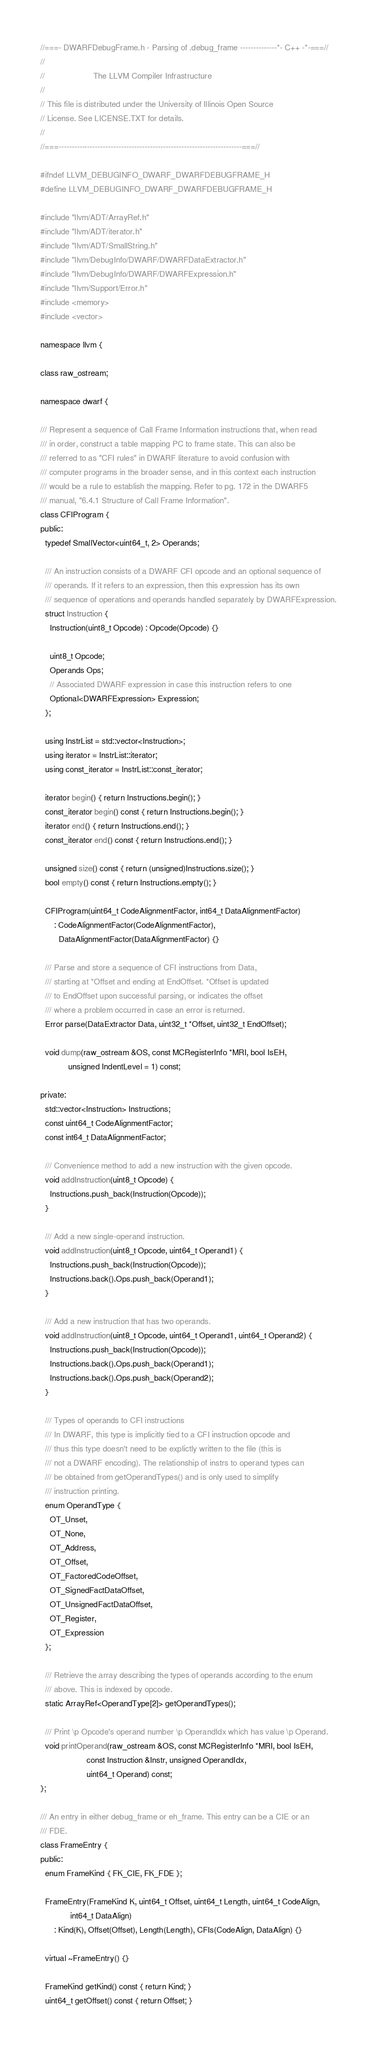Convert code to text. <code><loc_0><loc_0><loc_500><loc_500><_C_>//===- DWARFDebugFrame.h - Parsing of .debug_frame --------------*- C++ -*-===//
//
//                     The LLVM Compiler Infrastructure
//
// This file is distributed under the University of Illinois Open Source
// License. See LICENSE.TXT for details.
//
//===----------------------------------------------------------------------===//

#ifndef LLVM_DEBUGINFO_DWARF_DWARFDEBUGFRAME_H
#define LLVM_DEBUGINFO_DWARF_DWARFDEBUGFRAME_H

#include "llvm/ADT/ArrayRef.h"
#include "llvm/ADT/iterator.h"
#include "llvm/ADT/SmallString.h"
#include "llvm/DebugInfo/DWARF/DWARFDataExtractor.h"
#include "llvm/DebugInfo/DWARF/DWARFExpression.h"
#include "llvm/Support/Error.h"
#include <memory>
#include <vector>

namespace llvm {

class raw_ostream;

namespace dwarf {

/// Represent a sequence of Call Frame Information instructions that, when read
/// in order, construct a table mapping PC to frame state. This can also be
/// referred to as "CFI rules" in DWARF literature to avoid confusion with
/// computer programs in the broader sense, and in this context each instruction
/// would be a rule to establish the mapping. Refer to pg. 172 in the DWARF5
/// manual, "6.4.1 Structure of Call Frame Information".
class CFIProgram {
public:
  typedef SmallVector<uint64_t, 2> Operands;

  /// An instruction consists of a DWARF CFI opcode and an optional sequence of
  /// operands. If it refers to an expression, then this expression has its own
  /// sequence of operations and operands handled separately by DWARFExpression.
  struct Instruction {
    Instruction(uint8_t Opcode) : Opcode(Opcode) {}

    uint8_t Opcode;
    Operands Ops;
    // Associated DWARF expression in case this instruction refers to one
    Optional<DWARFExpression> Expression;
  };

  using InstrList = std::vector<Instruction>;
  using iterator = InstrList::iterator;
  using const_iterator = InstrList::const_iterator;

  iterator begin() { return Instructions.begin(); }
  const_iterator begin() const { return Instructions.begin(); }
  iterator end() { return Instructions.end(); }
  const_iterator end() const { return Instructions.end(); }

  unsigned size() const { return (unsigned)Instructions.size(); }
  bool empty() const { return Instructions.empty(); }

  CFIProgram(uint64_t CodeAlignmentFactor, int64_t DataAlignmentFactor)
      : CodeAlignmentFactor(CodeAlignmentFactor),
        DataAlignmentFactor(DataAlignmentFactor) {}

  /// Parse and store a sequence of CFI instructions from Data,
  /// starting at *Offset and ending at EndOffset. *Offset is updated
  /// to EndOffset upon successful parsing, or indicates the offset
  /// where a problem occurred in case an error is returned.
  Error parse(DataExtractor Data, uint32_t *Offset, uint32_t EndOffset);

  void dump(raw_ostream &OS, const MCRegisterInfo *MRI, bool IsEH,
            unsigned IndentLevel = 1) const;

private:
  std::vector<Instruction> Instructions;
  const uint64_t CodeAlignmentFactor;
  const int64_t DataAlignmentFactor;

  /// Convenience method to add a new instruction with the given opcode.
  void addInstruction(uint8_t Opcode) {
    Instructions.push_back(Instruction(Opcode));
  }

  /// Add a new single-operand instruction.
  void addInstruction(uint8_t Opcode, uint64_t Operand1) {
    Instructions.push_back(Instruction(Opcode));
    Instructions.back().Ops.push_back(Operand1);
  }

  /// Add a new instruction that has two operands.
  void addInstruction(uint8_t Opcode, uint64_t Operand1, uint64_t Operand2) {
    Instructions.push_back(Instruction(Opcode));
    Instructions.back().Ops.push_back(Operand1);
    Instructions.back().Ops.push_back(Operand2);
  }

  /// Types of operands to CFI instructions
  /// In DWARF, this type is implicitly tied to a CFI instruction opcode and
  /// thus this type doesn't need to be explictly written to the file (this is
  /// not a DWARF encoding). The relationship of instrs to operand types can
  /// be obtained from getOperandTypes() and is only used to simplify
  /// instruction printing.
  enum OperandType {
    OT_Unset,
    OT_None,
    OT_Address,
    OT_Offset,
    OT_FactoredCodeOffset,
    OT_SignedFactDataOffset,
    OT_UnsignedFactDataOffset,
    OT_Register,
    OT_Expression
  };

  /// Retrieve the array describing the types of operands according to the enum
  /// above. This is indexed by opcode.
  static ArrayRef<OperandType[2]> getOperandTypes();

  /// Print \p Opcode's operand number \p OperandIdx which has value \p Operand.
  void printOperand(raw_ostream &OS, const MCRegisterInfo *MRI, bool IsEH,
                    const Instruction &Instr, unsigned OperandIdx,
                    uint64_t Operand) const;
};

/// An entry in either debug_frame or eh_frame. This entry can be a CIE or an
/// FDE.
class FrameEntry {
public:
  enum FrameKind { FK_CIE, FK_FDE };

  FrameEntry(FrameKind K, uint64_t Offset, uint64_t Length, uint64_t CodeAlign,
             int64_t DataAlign)
      : Kind(K), Offset(Offset), Length(Length), CFIs(CodeAlign, DataAlign) {}

  virtual ~FrameEntry() {}

  FrameKind getKind() const { return Kind; }
  uint64_t getOffset() const { return Offset; }</code> 